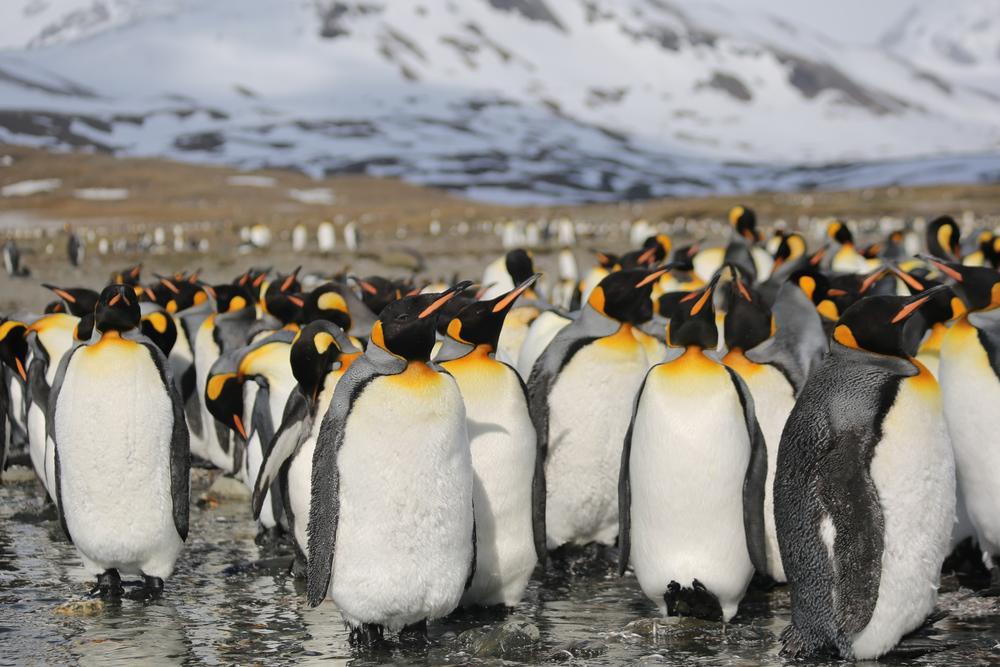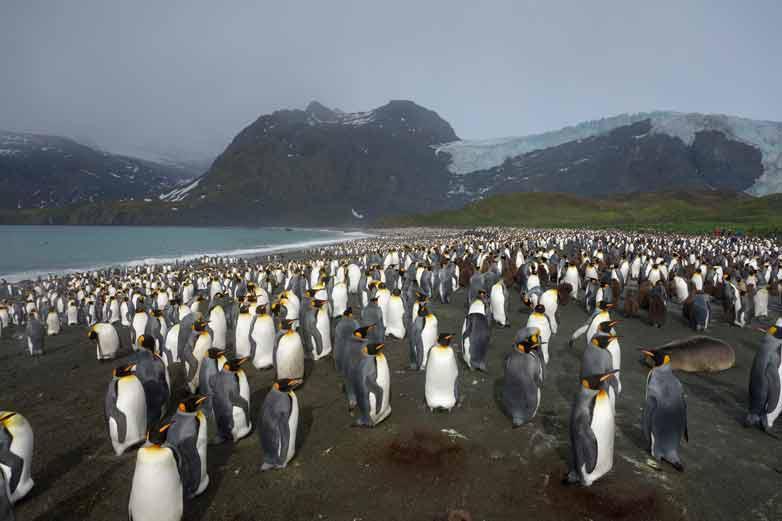The first image is the image on the left, the second image is the image on the right. Analyze the images presented: Is the assertion "At least one fuzzy brown chick is present." valid? Answer yes or no. Yes. The first image is the image on the left, the second image is the image on the right. Assess this claim about the two images: "A brown-feathered penguin is standing at the front of a mass of penguins.". Correct or not? Answer yes or no. No. 